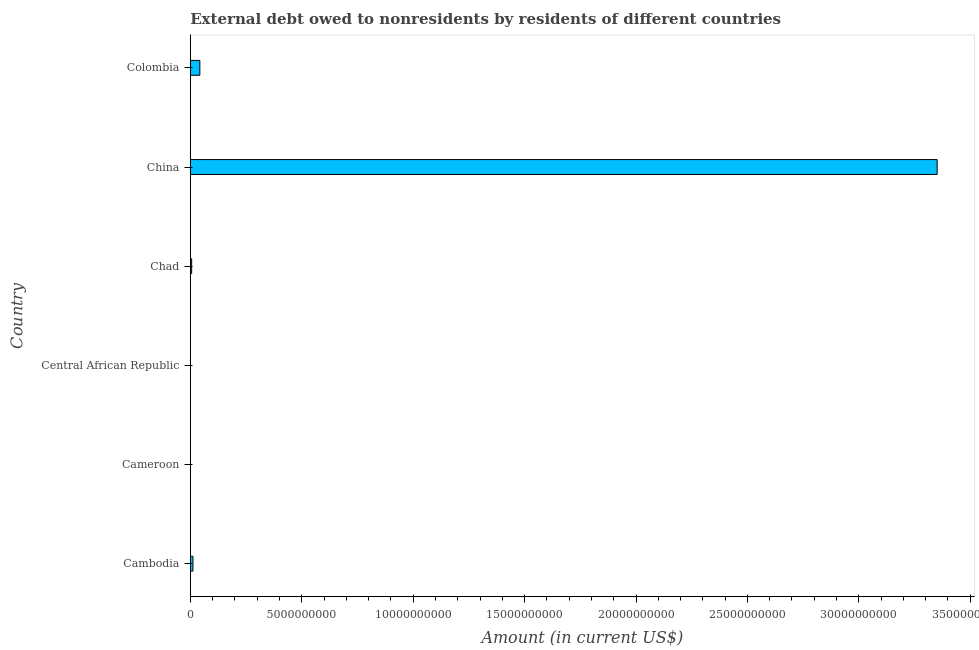Does the graph contain grids?
Offer a terse response. No. What is the title of the graph?
Provide a short and direct response. External debt owed to nonresidents by residents of different countries. What is the debt in Cameroon?
Your response must be concise. 0. Across all countries, what is the maximum debt?
Keep it short and to the point. 3.35e+1. Across all countries, what is the minimum debt?
Your response must be concise. 0. What is the sum of the debt?
Your answer should be very brief. 3.41e+1. What is the difference between the debt in China and Colombia?
Your answer should be compact. 3.31e+1. What is the average debt per country?
Offer a very short reply. 5.69e+09. What is the median debt?
Keep it short and to the point. 9.01e+07. In how many countries, is the debt greater than 6000000000 US$?
Offer a very short reply. 1. What is the ratio of the debt in Cambodia to that in Colombia?
Offer a very short reply. 0.28. Is the difference between the debt in Chad and Colombia greater than the difference between any two countries?
Your answer should be very brief. No. What is the difference between the highest and the second highest debt?
Offer a very short reply. 3.31e+1. What is the difference between the highest and the lowest debt?
Offer a terse response. 3.35e+1. Are all the bars in the graph horizontal?
Your response must be concise. Yes. How many countries are there in the graph?
Provide a succinct answer. 6. What is the Amount (in current US$) of Cambodia?
Make the answer very short. 1.19e+08. What is the Amount (in current US$) of Central African Republic?
Provide a short and direct response. 0. What is the Amount (in current US$) in Chad?
Your answer should be very brief. 6.11e+07. What is the Amount (in current US$) of China?
Provide a succinct answer. 3.35e+1. What is the Amount (in current US$) of Colombia?
Offer a terse response. 4.29e+08. What is the difference between the Amount (in current US$) in Cambodia and Chad?
Give a very brief answer. 5.82e+07. What is the difference between the Amount (in current US$) in Cambodia and China?
Offer a very short reply. -3.34e+1. What is the difference between the Amount (in current US$) in Cambodia and Colombia?
Keep it short and to the point. -3.09e+08. What is the difference between the Amount (in current US$) in Chad and China?
Provide a short and direct response. -3.35e+1. What is the difference between the Amount (in current US$) in Chad and Colombia?
Keep it short and to the point. -3.68e+08. What is the difference between the Amount (in current US$) in China and Colombia?
Make the answer very short. 3.31e+1. What is the ratio of the Amount (in current US$) in Cambodia to that in Chad?
Provide a succinct answer. 1.95. What is the ratio of the Amount (in current US$) in Cambodia to that in China?
Keep it short and to the point. 0. What is the ratio of the Amount (in current US$) in Cambodia to that in Colombia?
Give a very brief answer. 0.28. What is the ratio of the Amount (in current US$) in Chad to that in China?
Ensure brevity in your answer.  0. What is the ratio of the Amount (in current US$) in Chad to that in Colombia?
Offer a very short reply. 0.14. What is the ratio of the Amount (in current US$) in China to that in Colombia?
Your answer should be compact. 78.19. 